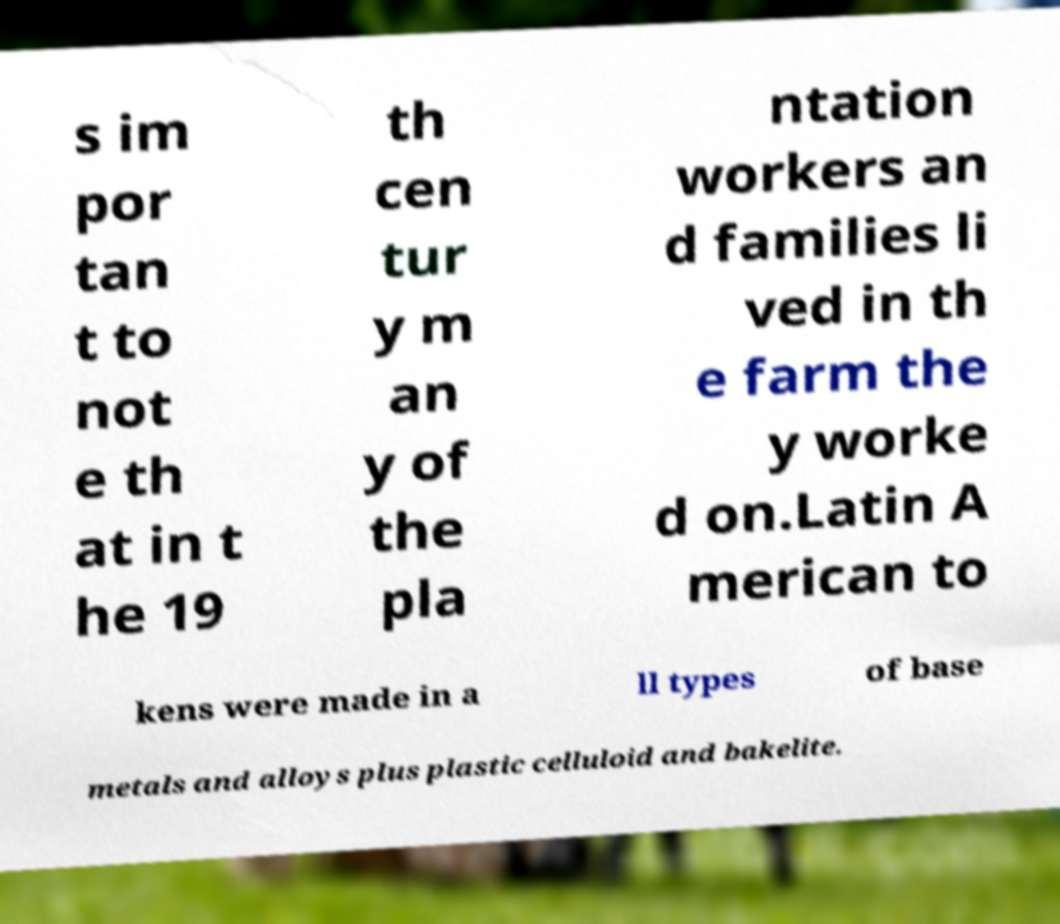Can you read and provide the text displayed in the image?This photo seems to have some interesting text. Can you extract and type it out for me? s im por tan t to not e th at in t he 19 th cen tur y m an y of the pla ntation workers an d families li ved in th e farm the y worke d on.Latin A merican to kens were made in a ll types of base metals and alloys plus plastic celluloid and bakelite. 